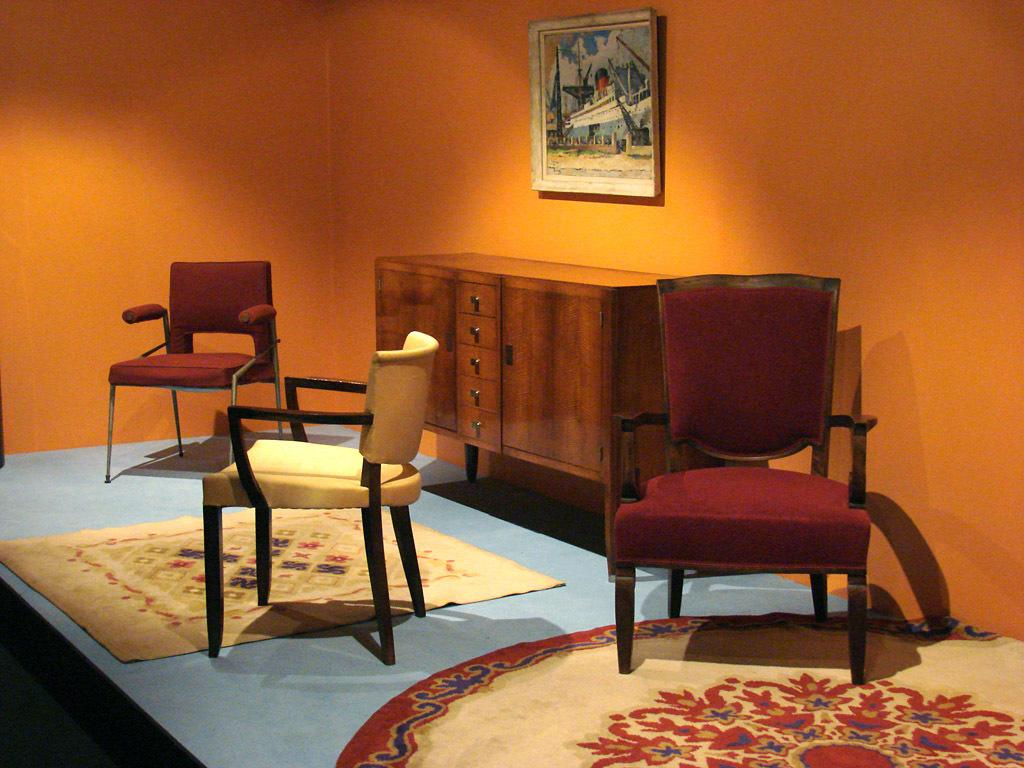How many chairs are visible in the image? There are 3 chairs in the image. What type of furniture is also present in the image? There is a cupboard in the image. Can you describe something on the wall in the image? There is a photo frame on the wall in the image. What action is the van performing in the image? There is no van present in the image. How many tickets are visible in the image? There are no tickets visible in the image. 